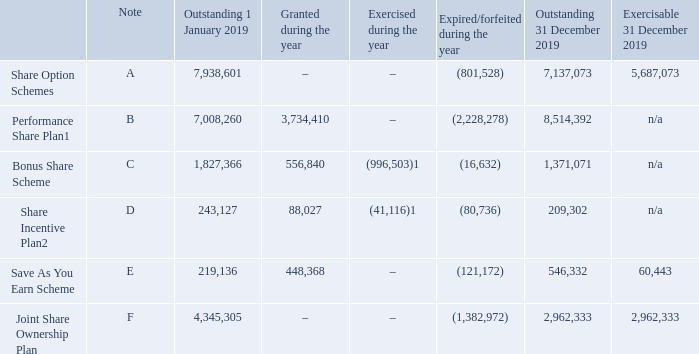7 Employees’ information (continued)
Share based payments
Details of share options outstanding under each of the Group’s schemes is set out below:
1 Shares ordinarily exercised immediately on vested date.
2 Relates to non-vested SIP free shares, partnership shares and matching shares granted.
The weighted average exercise prices of the outstanding options and outstanding options exercisable at 31 December 2019 for the Share Option Schemes were 304 pence and 309 pence respectively (2018: 302 pence and 309 pence respectively) and for the Save As You Earn Scheme were 77 pence and 278 respectively (2018: 224 pence and nil respectively).
A Share Option Schemes
Options to subscribe for ordinary shares may be awarded under the intu properties plc Company Share Option Plan and the intu properties plc Non-approved Executive Share Option Scheme.
Such options may not be exercised within three years of grant or before the satisfaction or waiver of any applicable performance conditions and will be forfeited if the employee leaves the Group before their options become capable of exercise, except in certain circumstances. The options will lapse if not exercised within 10 years of the date of grant.
B Performance Share Plan (PSP)
The Company operates a PSP for eligible employees at the discretion of the Remuneration Committee
Awards may be made in the form of nil cost options, a conditional share award or prior to April 2019, a joint share ownership award and fixed-value zero-cost option, and eligible employees may be granted any combination of such awards subject to any individual limits.
The 2020 PSP awards will vest based on (i) 50 per cent of each award – relative Total Shareholder Return vs a bespoke real estate sector peer group (this group being expanded from the very small groups used previously) and (ii) 50 per cent of each award – intu’s Total Property Return vs the MSCI UK Shopping Centre benchmark. This mix of metrics represents a change from the 2019 awards which were based 50 per cent each on relative and absolute TSR targets subject to a Remuneration Committee-operated discretionary assessment of underlying financial performance. It is intended that awards will vest three years following grant (with an additional two year post vesting holding period applying to the net number of shares that vest if the Remuneration Committee considers it appropriate to apply such additional condition).
C Bonus Share Scheme (Bonus Scheme)
Under the Company’s Bonus Scheme, shares may be awarded on a deferred basis as part of a bonus award (Deferred Share Awards).
Deferred Share Awards comprise Restricted Shares and Additional Shares (prior to July 2019). Restricted Shares will vest two or three years after the date of their award and Additional Shares will vest four or five years after the date of award. Vesting is subject, under normal circumstances, to continued employment during the vesting or ‘restricted’ period. There are no further performance conditions applicable to either Restricted Shares or Additional Shares.
Where awarded, the number of Additional Shares would be equal to 50 per cent of the combined total of shares awarded as Restricted Shares and under the Share Incentive Plan (see section D). No Additional Shares were outstanding at 1 January 2014 and no awards of Additional Shares have been made since this time. intu properties
D Share Incentive Plan (SIP)
The Company operates a SIP for all eligible employees, who may receive up to £3,600 worth of shares (Free Shares) as part of their annual bonus. The SIP is an HMRC tax-advantaged scheme.
Any Free Shares awarded under the SIP will be held in trust on behalf of each employee for at least three years following grant, after which time they may be withdrawn, provided the individual employee has remained in employment with the Company. If the Free Shares are held in trust for a further two years, they will qualify for HMRC-approved tax advantages.
As part of the SIP arrangements, the Company also offers eligible employees the opportunity to participate in a Partnership share scheme, under which employees can invest up to £1,800 of pre-tax salary (or, if less, 10 per cent of salary) in any tax year, which will be used to purchase ordinary shares in the Company (Partnership Shares) at the end of a 12-month period. The Group will give each employee one ordinary share (a Matching Share) for every two Partnership Shares purchased by the employee. Matching Shares will be forfeited if the employee leaves the Group within three years of the date of award and will qualify for HMRC-approved tax advantages if they are held in the SIP for five years.
E Save As You Earn Scheme (SAYE)
The Group operates a SAYE under which all eligible UK employees may save up to a maximum of £500 per month for a period of three or five years and use the proceeds at the end of their saving period to purchase shares in the Company. At the start of the saving period, each SAYE participant will be granted an option to purchase such shares at a price usually determined as the average mid-market closing share price of an ordinary share in the Company over the three consecutive dealing days preceding the SAYE invitation date, discounted by up to 20 per cent. Options may normally be exercised within six months following the end of the savings period.
F Joint Share Ownership Plan (JSOP)
Eligible employees were invited to participate in the JSOP which formed part of the intu properties plc Unapproved Share Option Scheme (which was replaced by the Non-approved Executive Share Option Scheme upon its expiry in April 2018) and the PSP. Under the JSOP, shares are held jointly by the employee and the employee share ownership plan trustee with any increases in the share price and dividends paid on those shares being allocated between the joint owners in accordance with the terms of the scheme.
Conditions under which JSOP interests may be exercised (including applicable performance conditions) are the same as those for the Non-approved Executive Share Option Scheme as outlined in section A.
What is the weighted average exercise prices of the outstanding options at 31 December 2019 for the Share Option Schemes? 304 pence. When will the options lapse? If not exercised within 10 years of the date of grant. What is the weighted average exercise prices of the outstanding options exercisable at 31 December 2019 for the Save As You Earn Scheme? 278. What is the percentage change in the outstanding shares under the share options scheme from 1 January 2019 to 31 December 2019?
Answer scale should be: percent. (7,137,073-7,938,601)/7,938,601
Answer: -10.1. What is the percentage change in the outstanding shares under the performance share plan from 1 January 2019 to 31 December 2019?
Answer scale should be: percent. (8,514,392-7,008,260)/7,008,260
Answer: 21.49. What is the percentage change in the outstanding shares under the Save As You Earn Scheme from 1 January 2019 to 31 December 2019?
Answer scale should be: percent. (546,332-219,136)/219,136
Answer: 149.31. 